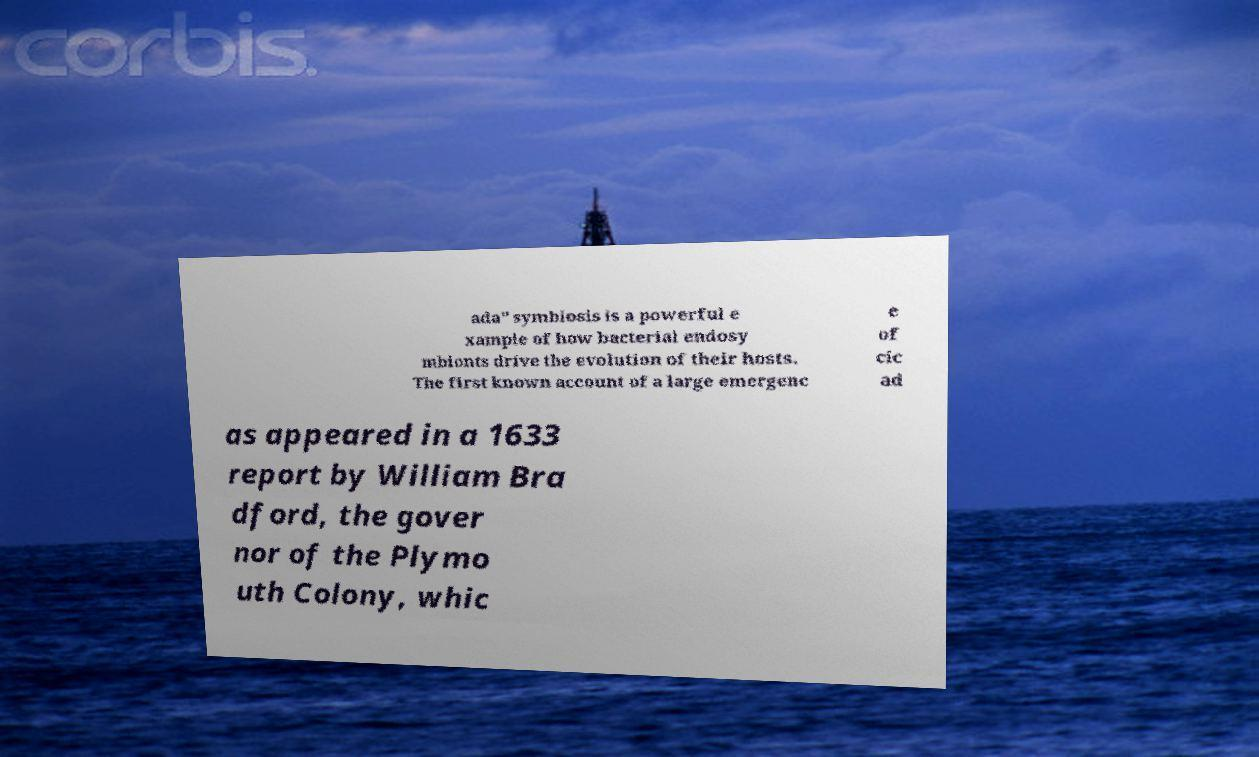Can you read and provide the text displayed in the image?This photo seems to have some interesting text. Can you extract and type it out for me? ada" symbiosis is a powerful e xample of how bacterial endosy mbionts drive the evolution of their hosts. The first known account of a large emergenc e of cic ad as appeared in a 1633 report by William Bra dford, the gover nor of the Plymo uth Colony, whic 